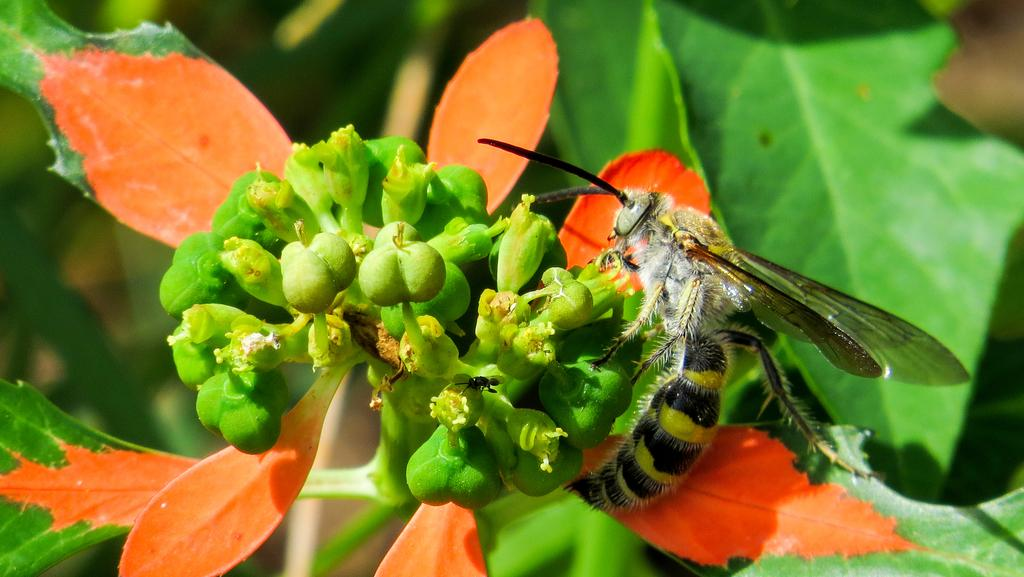What is the main subject in the center of the image? There is a flower in the middle of the image. Is there anything on the flower? Yes, there is an insect on the flower. What can be seen behind the flower? There are leaves visible behind the flower. How many grapes are hanging from the flower in the image? There are no grapes present in the image; it features a flower with an insect on it and leaves behind it. What type of screw is used to support the flower in the image? There is no screw present in the image; the flower is naturally supported by its stem and leaves. 